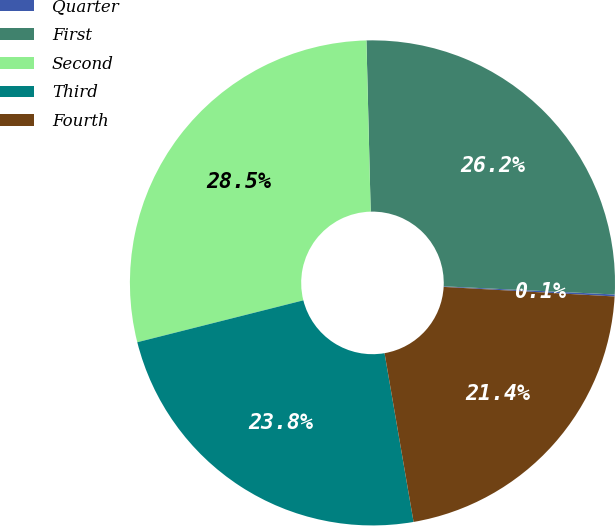<chart> <loc_0><loc_0><loc_500><loc_500><pie_chart><fcel>Quarter<fcel>First<fcel>Second<fcel>Third<fcel>Fourth<nl><fcel>0.13%<fcel>26.16%<fcel>28.54%<fcel>23.78%<fcel>21.4%<nl></chart> 